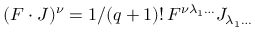<formula> <loc_0><loc_0><loc_500><loc_500>( F \cdot J ) ^ { \nu } = 1 / ( q + 1 ) ! \, F ^ { \nu \lambda _ { 1 } \dots } J _ { \lambda _ { 1 } \dots }</formula> 